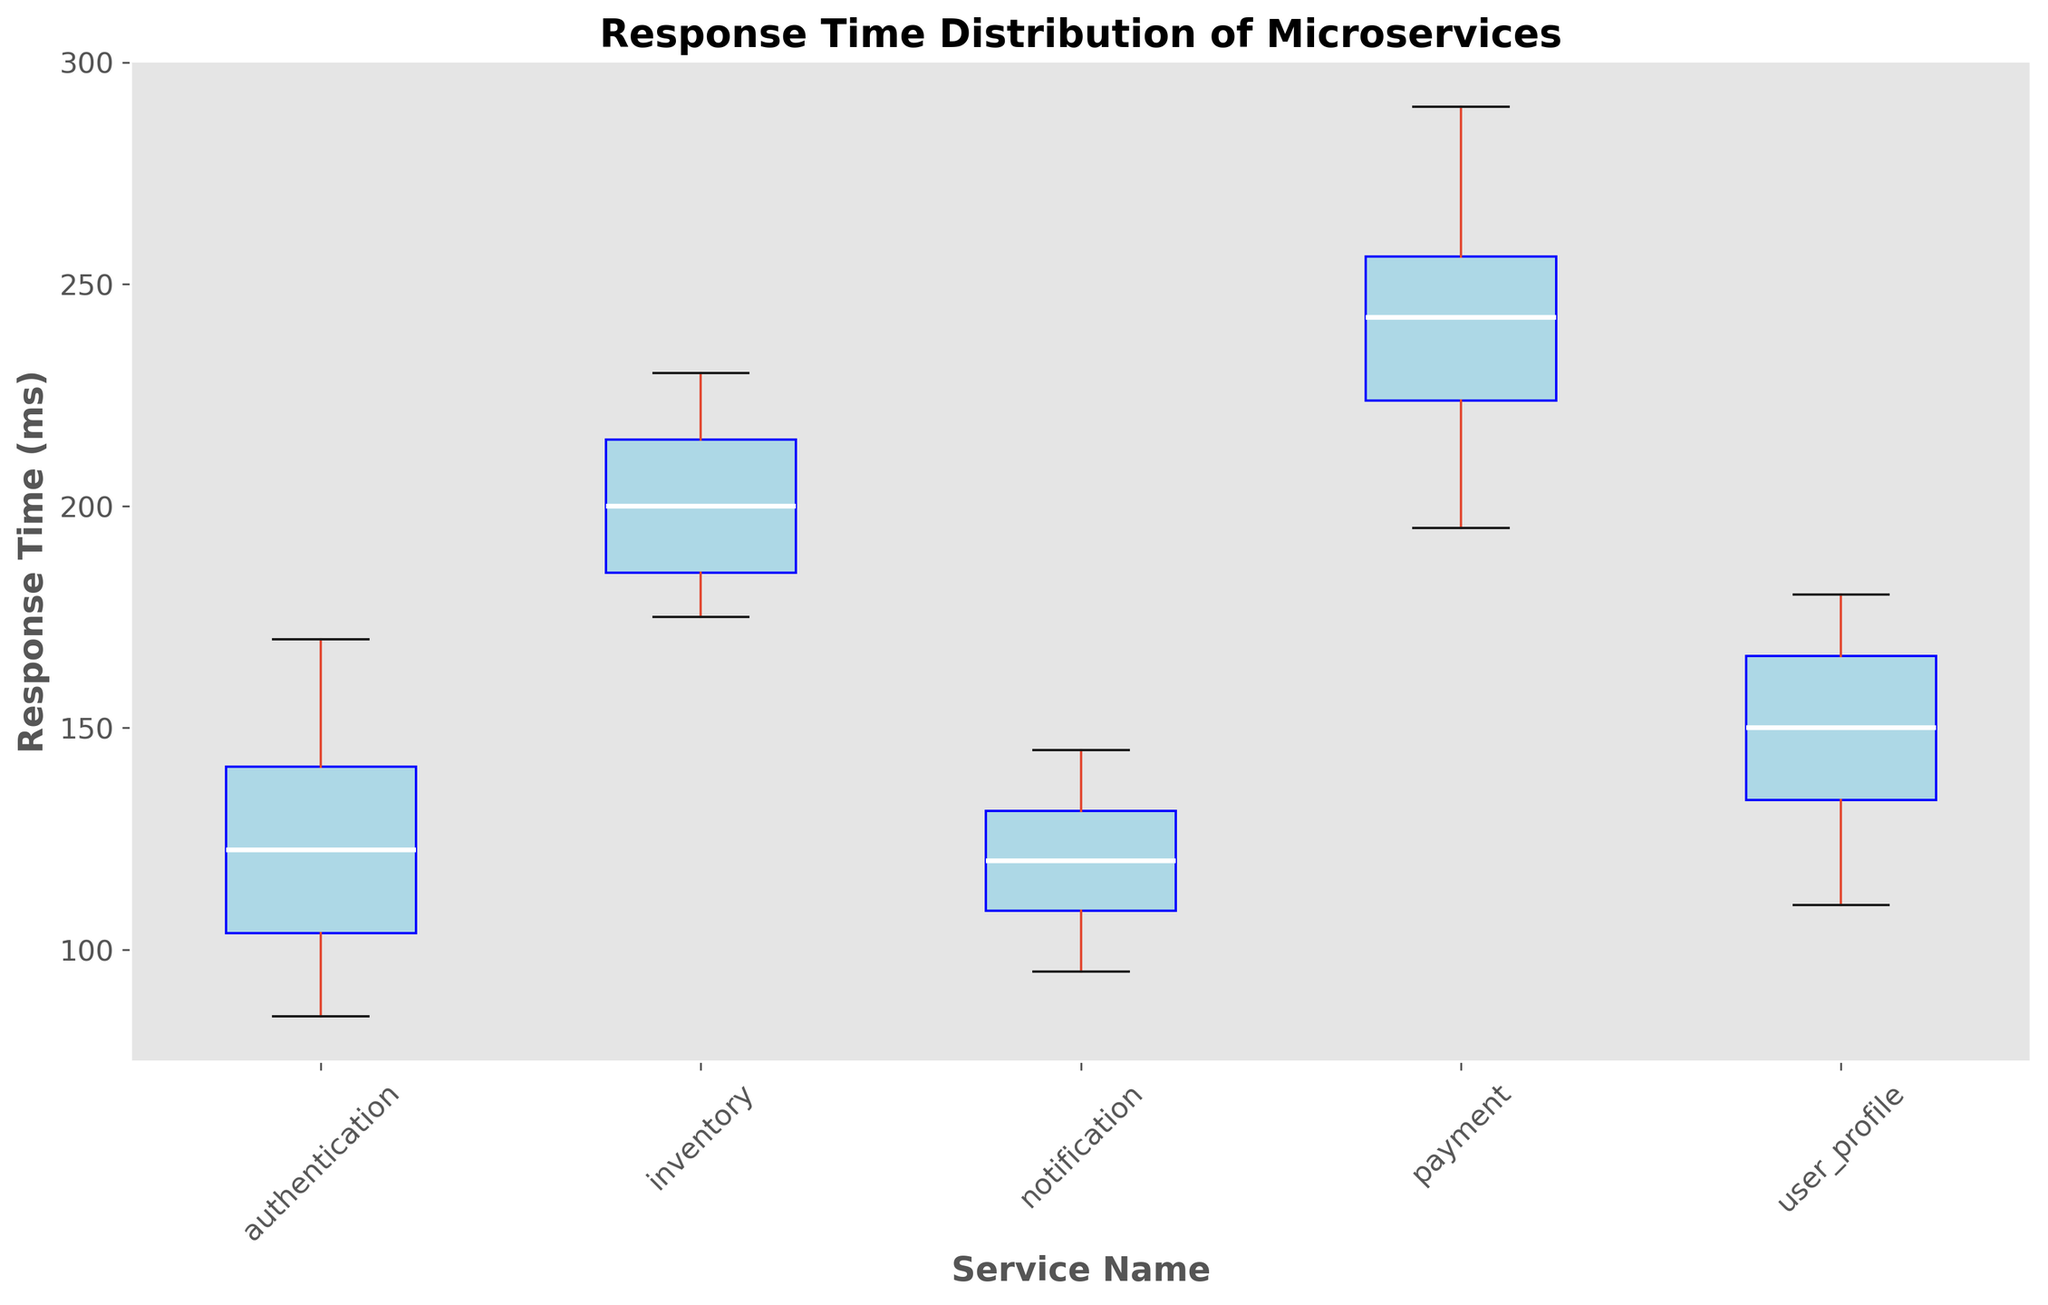what microservice has the widest interquartile range (IQR) for response times? To find the microservice with the widest IQR, we compare the length of the boxes for each microservice. The IQR is the range between the first quartile (Q1) and third quartile (Q3). In the box plot, this is the length of the box. Upon comparison, the "payment" service has the widest interquartile range.
Answer: payment what is the median response time for the authentication service? The median response time is represented by the white line within the box for the "authentication" service. By visually identifying the white line within the "authentication" box, we can determine that the median response time is around 120 ms.
Answer: 120 ms between which two microservices is the difference in median response times the greatest? To find the greatest difference, we look at the white lines (medians) in each box and compare them. The "payment" service has a median around 250 ms, and the "notification" service has a median around 120 ms, leading to the greatest median difference of approximately 130 ms.
Answer: payment and notification which microservice has the smallest range (difference between max and min values) of response times? To determine the smallest range, we identify the vertical distances from the minimum to the maximum whiskers within each box. The "notification" service has the shortest vertical distance between these whiskers, indicating the smallest range.
Answer: notification are there any microservices with similar median response times? We compare the median lines (white lines) across the boxes. Both "authentication" and "notification" services have very similar median response times, closely aligned around the 120 ms mark.
Answer: authentication and notification which microservice has the highest maximum response time? The maximum response time is indicated by the uppermost whisker of each box. The "payment" service has the highest maximum response time, reaching up to around 290 ms.
Answer: payment which two microservices have the most similar interquartile ranges? By comparing the lengths of the boxes, we find that the "authentication" and "user_profile" services have similar IQRs, indicating that their response times' middle 50% are distributed similarly.
Answer: authentication and user_profile among all microservices, which one has the largest number of outliers? Outliers are represented as individual points outside the whiskers. By counting these points, the "payment" service has the largest number of outliers.
Answer: payment 